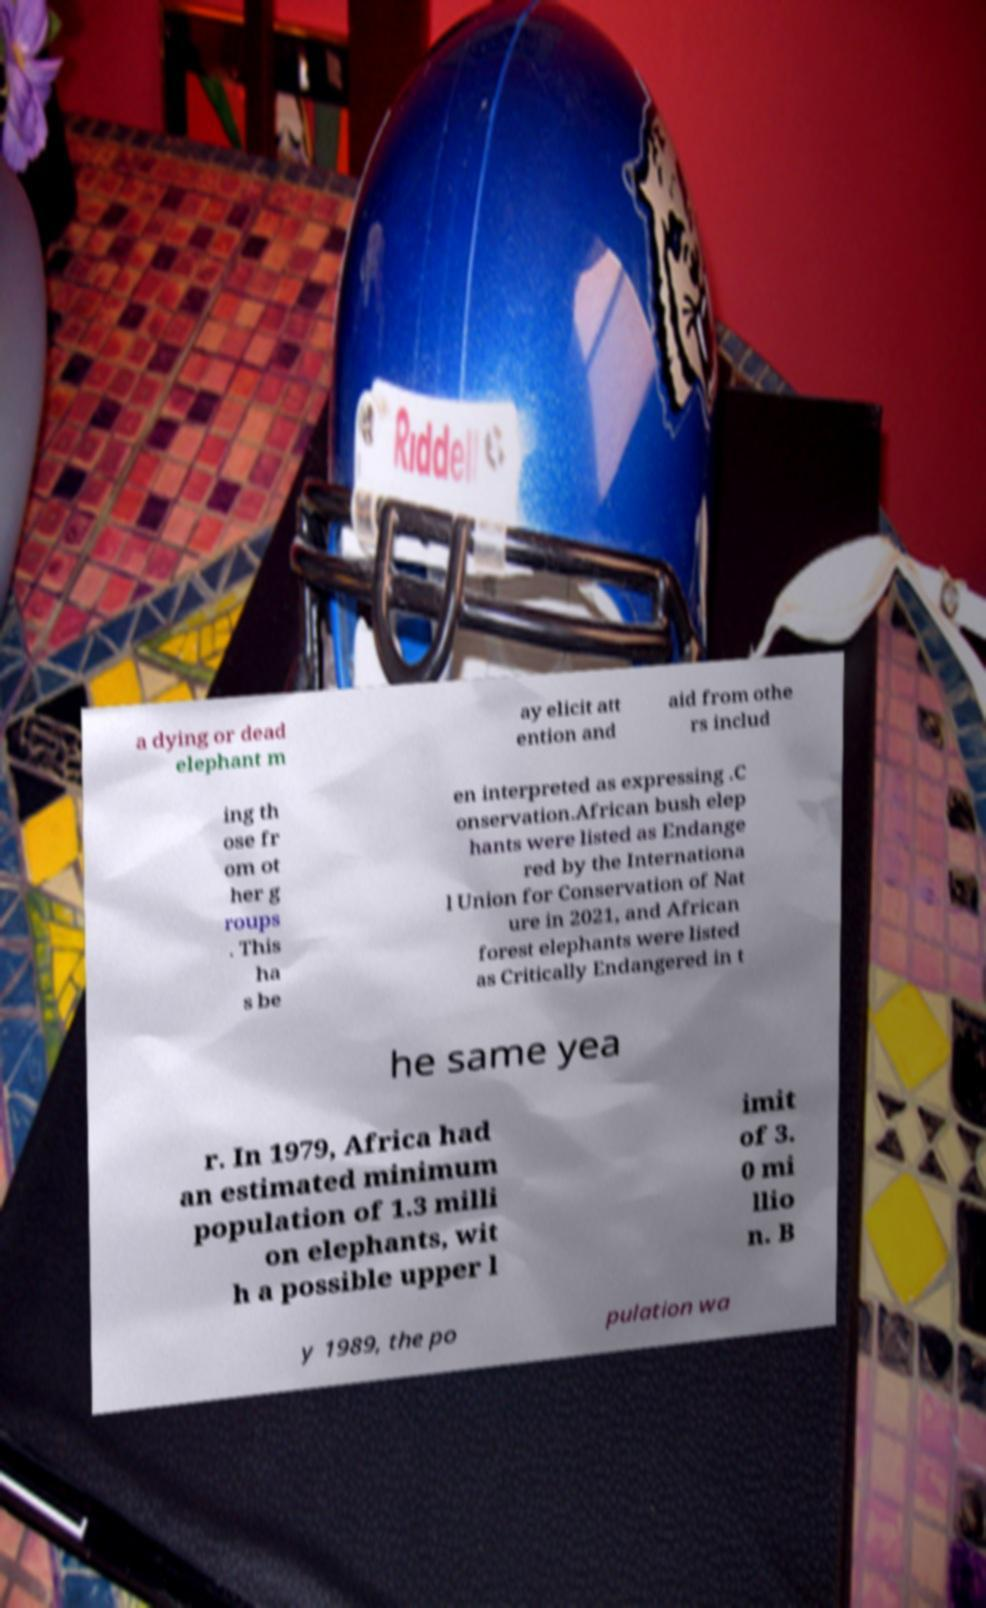Can you accurately transcribe the text from the provided image for me? a dying or dead elephant m ay elicit att ention and aid from othe rs includ ing th ose fr om ot her g roups . This ha s be en interpreted as expressing .C onservation.African bush elep hants were listed as Endange red by the Internationa l Union for Conservation of Nat ure in 2021, and African forest elephants were listed as Critically Endangered in t he same yea r. In 1979, Africa had an estimated minimum population of 1.3 milli on elephants, wit h a possible upper l imit of 3. 0 mi llio n. B y 1989, the po pulation wa 